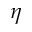Convert formula to latex. <formula><loc_0><loc_0><loc_500><loc_500>\eta</formula> 